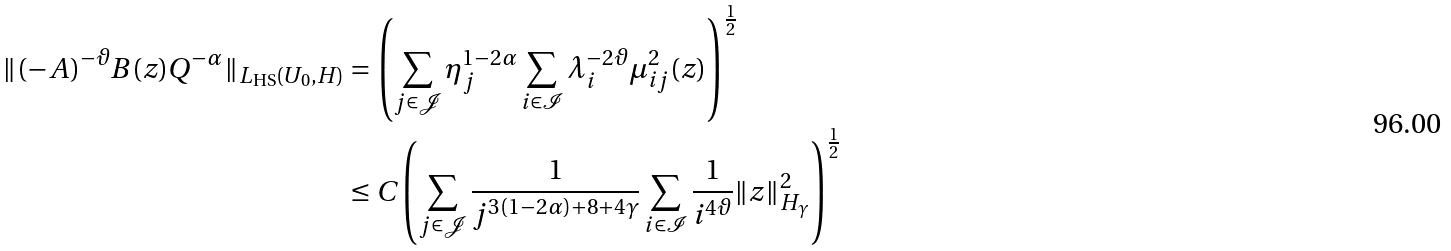<formula> <loc_0><loc_0><loc_500><loc_500>\| ( - A ) ^ { - \vartheta } B ( z ) Q ^ { - \alpha } \| _ { L _ { \text {HS} } ( U _ { 0 } , H ) } & = \left ( \sum _ { j \in \mathcal { J } } \eta _ { j } ^ { 1 - 2 \alpha } \sum _ { i \in \mathcal { I } } \lambda _ { i } ^ { - 2 \vartheta } \mu _ { i j } ^ { 2 } ( z ) \right ) ^ { \frac { 1 } { 2 } } \\ & \leq C \left ( \sum _ { j \in \mathcal { J } } \frac { 1 } { j ^ { 3 ( 1 - 2 \alpha ) + 8 + 4 \gamma } } \sum _ { i \in \mathcal { I } } \frac { 1 } { i ^ { 4 \vartheta } } \| z \| _ { H _ { \gamma } } ^ { 2 } \right ) ^ { \frac { 1 } { 2 } }</formula> 